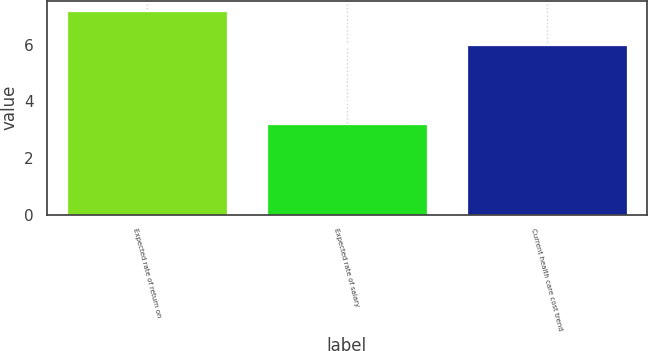<chart> <loc_0><loc_0><loc_500><loc_500><bar_chart><fcel>Expected rate of return on<fcel>Expected rate of salary<fcel>Current health care cost trend<nl><fcel>7.2<fcel>3.2<fcel>6<nl></chart> 